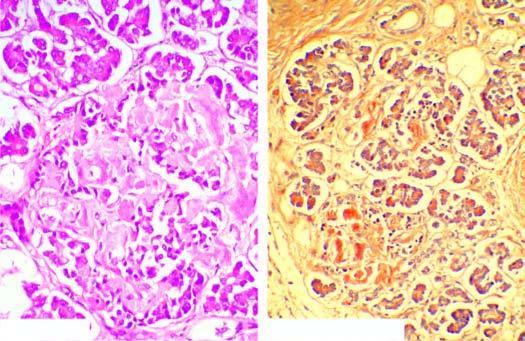re koilocytes and virus-infected keratinocytes mostly replaced by structureless eosinophilic material which stains positively with congo red?
Answer the question using a single word or phrase. No 